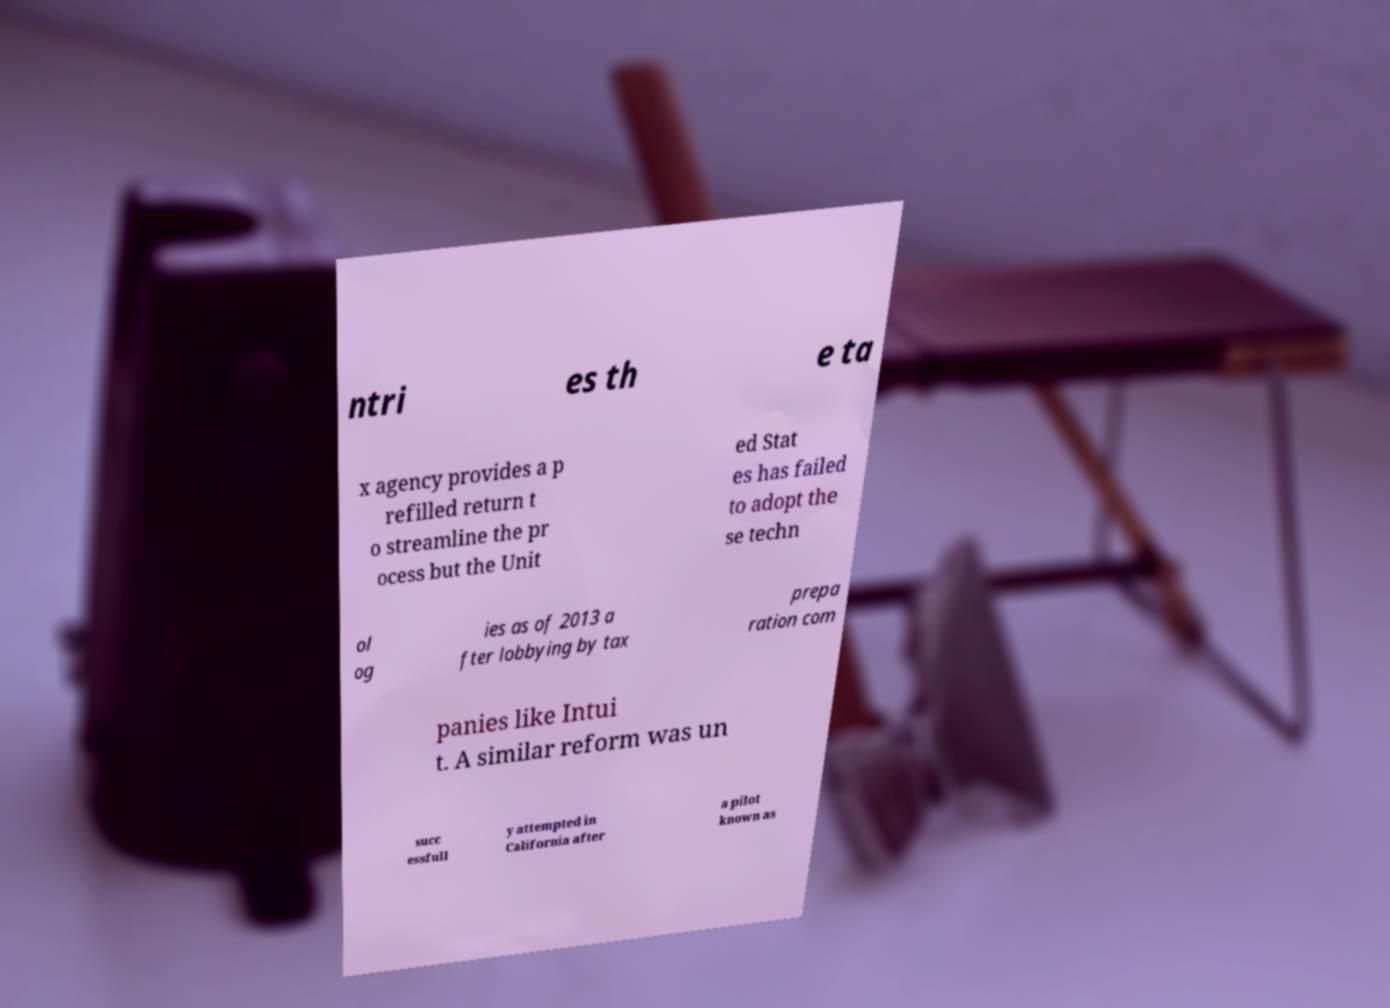I need the written content from this picture converted into text. Can you do that? ntri es th e ta x agency provides a p refilled return t o streamline the pr ocess but the Unit ed Stat es has failed to adopt the se techn ol og ies as of 2013 a fter lobbying by tax prepa ration com panies like Intui t. A similar reform was un succ essfull y attempted in California after a pilot known as 